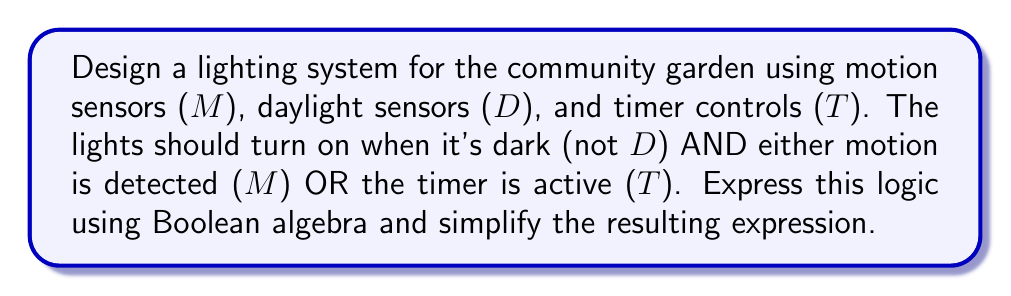Give your solution to this math problem. Let's approach this step-by-step:

1) First, we need to express the conditions for the lights to turn on in Boolean algebra:
   - It's dark: $\overline{D}$ (not D)
   - Motion is detected OR timer is active: $M + T$

2) The lights should turn on when both conditions are true, so we use the AND operator:

   $L = \overline{D} \cdot (M + T)$

   Where $L$ represents the lights being on.

3) Now, let's simplify this expression using Boolean algebra laws:

   $L = \overline{D} \cdot (M + T)$

4) We can distribute $\overline{D}$ over $(M + T)$ using the distributive law:

   $L = (\overline{D} \cdot M) + (\overline{D} \cdot T)$

5) This expression is already in its simplest form, known as the sum of products (SOP) form.

6) We can interpret this as:
   The lights will be on when it's dark AND motion is detected, OR when it's dark AND the timer is active.

This simplified expression represents the most efficient logic for the eco-friendly lighting system in the community garden.
Answer: $L = (\overline{D} \cdot M) + (\overline{D} \cdot T)$ 